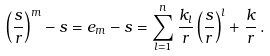Convert formula to latex. <formula><loc_0><loc_0><loc_500><loc_500>\left ( \frac { s } { r } \right ) ^ { m } - s = e _ { m } - s = \sum _ { l = 1 } ^ { n } \frac { k _ { l } } { r } \left ( \frac { s } { r } \right ) ^ { l } + \frac { k } { r } \, .</formula> 